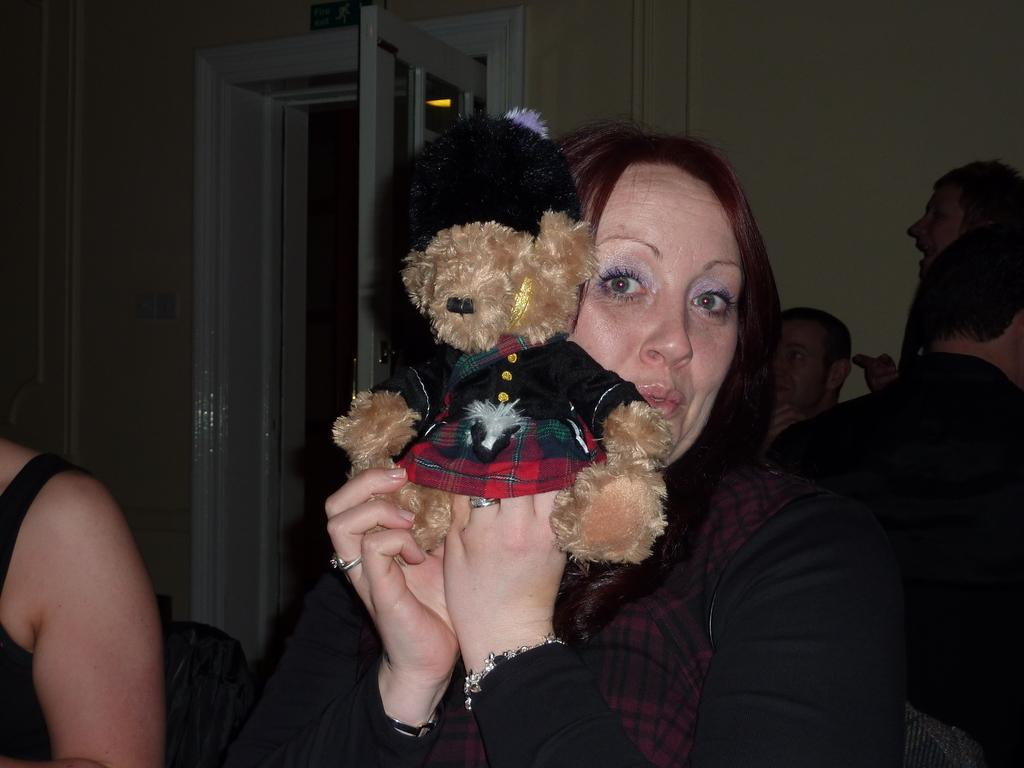How many people are in the image? There is a group of people in the image. What is the woman holding in the image? The woman is holding a soft toy in the image. What can be seen in the background of the image? There is a wall and a door in the background of the image. How many chairs are visible in the image? There are no chairs visible in the image. What type of ink is being used by the people in the image? There is no ink present in the image; it is a group of people and a woman holding a soft toy. 